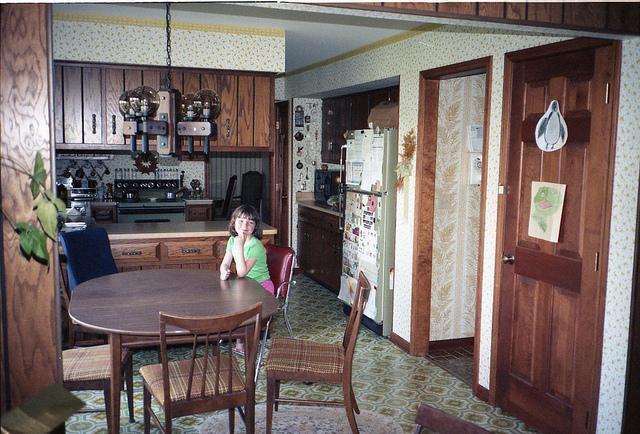In what is the most likely type of structure is this room?
Select the correct answer and articulate reasoning with the following format: 'Answer: answer
Rationale: rationale.'
Options: Bridge, house, store, skyscraper. Answer: house.
Rationale: This looks like a residential kitchen so this must be a house. 